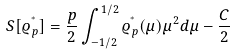Convert formula to latex. <formula><loc_0><loc_0><loc_500><loc_500>S [ \varrho _ { p } ^ { ^ { * } } ] = \frac { p } { 2 } \int _ { - 1 / 2 } ^ { 1 / 2 } \varrho _ { p } ^ { ^ { * } } ( \mu ) { \mu } ^ { 2 } d \mu - \frac { C } { 2 }</formula> 